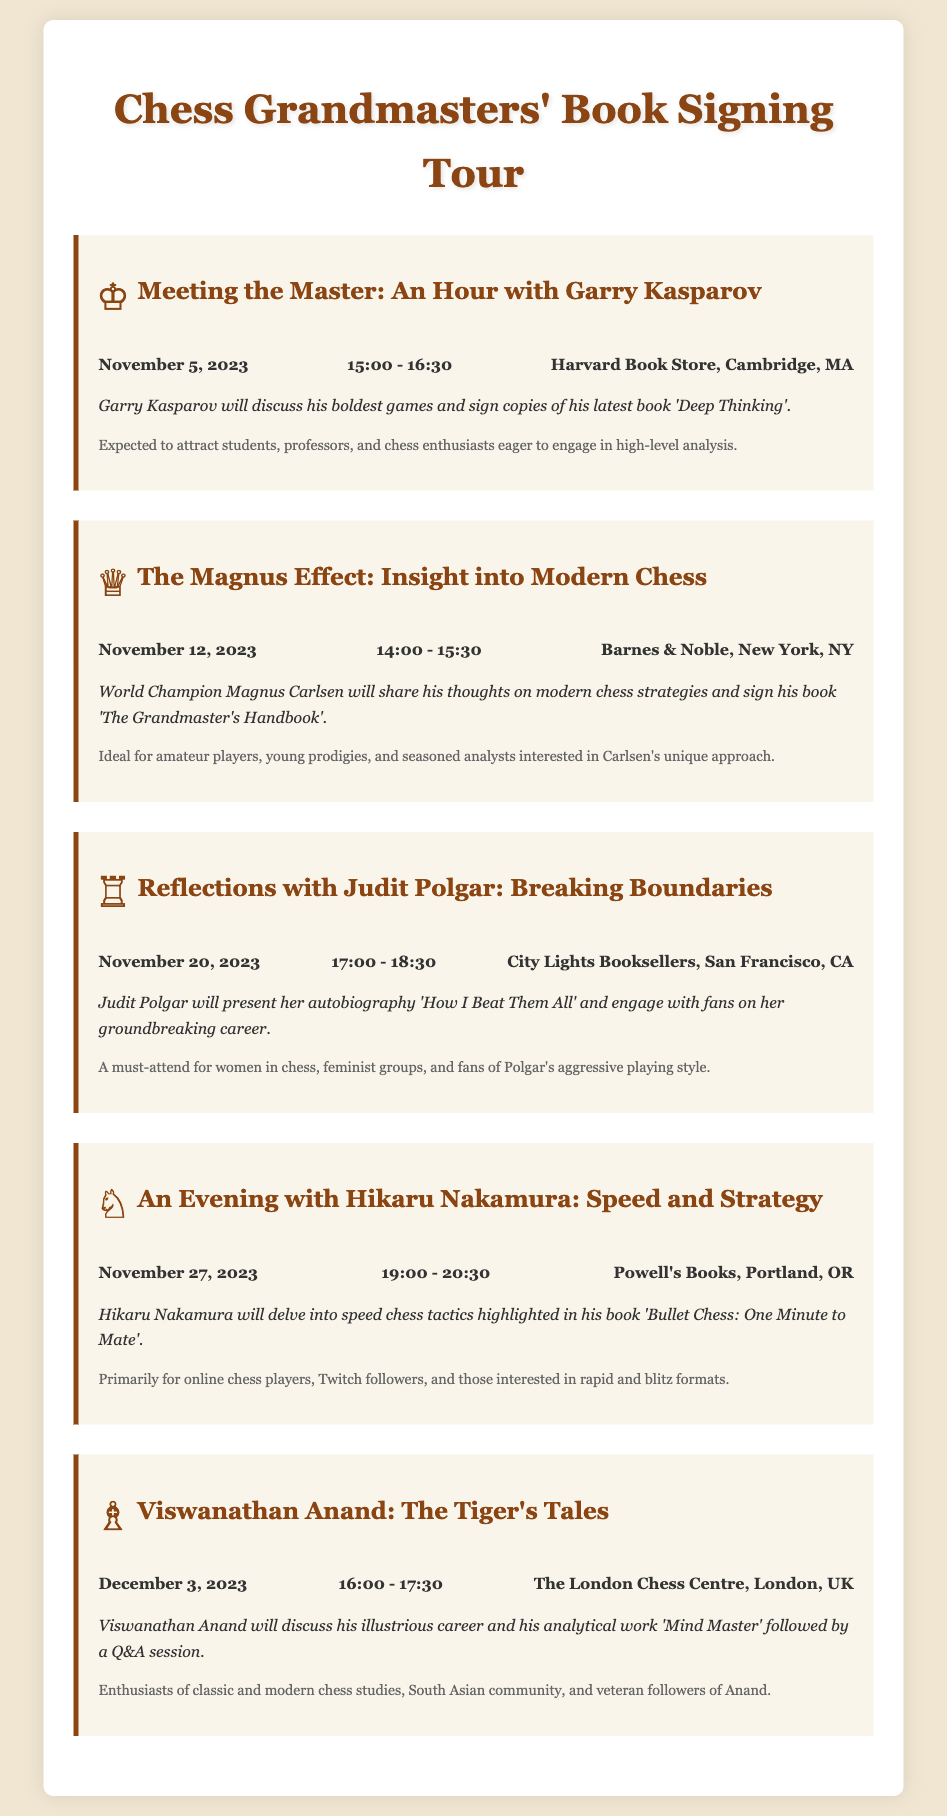What is the date of Garry Kasparov's book signing? The document specifies that Garry Kasparov's event is scheduled for November 5, 2023.
Answer: November 5, 2023 Where will the event with Magnus Carlsen take place? According to the document, Magnus Carlsen's signing will be held at Barnes & Noble, New York, NY.
Answer: Barnes & Noble, New York, NY What is the title of Judit Polgar's autobiography? The document mentions her autobiography is titled 'How I Beat Them All'.
Answer: How I Beat Them All Which grandmaster is associated with speed chess tactics? The document indicates Hikaru Nakamura will be discussing speed chess tactics.
Answer: Hikaru Nakamura Who will be in attendance at the event in London? Viswanathan Anand is expected to be at The London Chess Centre for his event.
Answer: Viswanathan Anand How long is Garry Kasparov's event scheduled to last? The document notes that Kasparov's event is from 15:00 to 16:30, which is 1.5 hours.
Answer: 1.5 hours What type of audience is expected for Judit Polgar's event? The insights mention that it is a must-attend for women in chess and feminist groups.
Answer: Women in chess, feminist groups What is the main topic for Hikaru Nakamura's discussion? The document states that he will delve into speed chess tactics.
Answer: Speed chess tactics What event follows Magnus Carlsen's signing? According to the calendar, the next event is with Judit Polgar on November 20, 2023.
Answer: Judit Polgar on November 20, 2023 